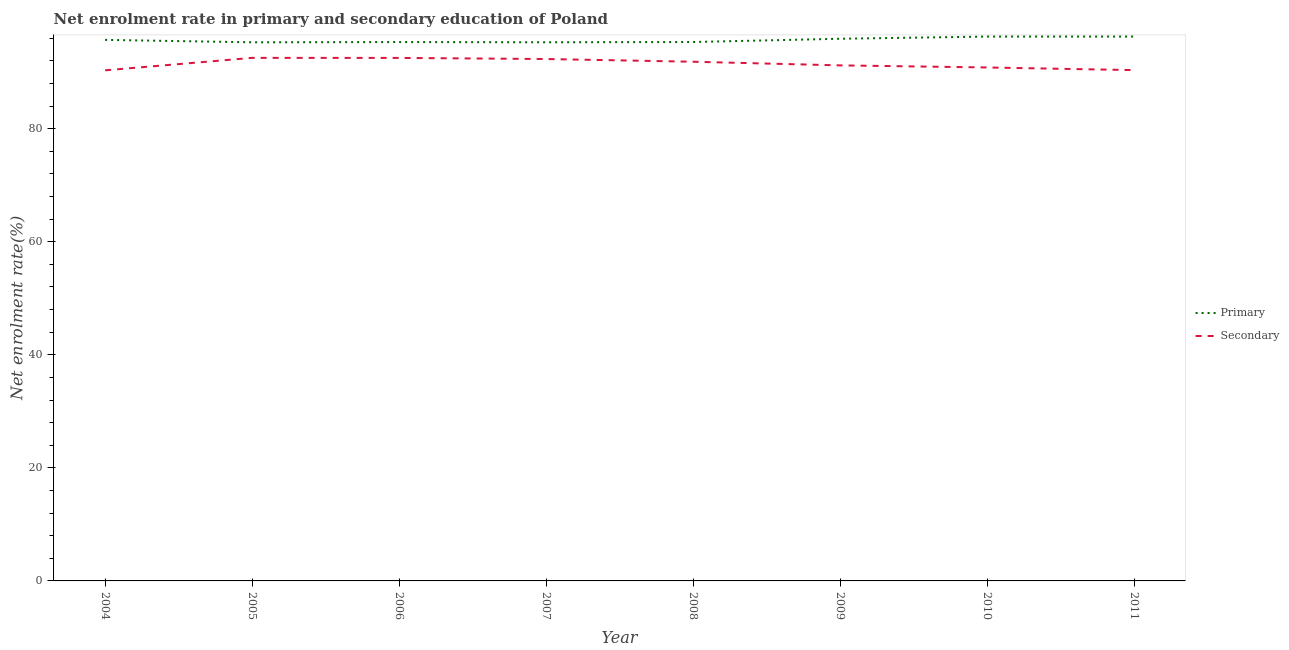What is the enrollment rate in primary education in 2007?
Offer a very short reply. 95.29. Across all years, what is the maximum enrollment rate in primary education?
Ensure brevity in your answer.  96.3. Across all years, what is the minimum enrollment rate in secondary education?
Your answer should be compact. 90.33. What is the total enrollment rate in primary education in the graph?
Make the answer very short. 765.48. What is the difference between the enrollment rate in primary education in 2005 and that in 2007?
Offer a very short reply. -0. What is the difference between the enrollment rate in primary education in 2009 and the enrollment rate in secondary education in 2005?
Make the answer very short. 3.38. What is the average enrollment rate in primary education per year?
Make the answer very short. 95.69. In the year 2007, what is the difference between the enrollment rate in primary education and enrollment rate in secondary education?
Your answer should be very brief. 2.96. What is the ratio of the enrollment rate in primary education in 2006 to that in 2008?
Provide a short and direct response. 1. What is the difference between the highest and the second highest enrollment rate in secondary education?
Ensure brevity in your answer.  0.01. What is the difference between the highest and the lowest enrollment rate in primary education?
Your answer should be compact. 1.01. Is the sum of the enrollment rate in secondary education in 2007 and 2010 greater than the maximum enrollment rate in primary education across all years?
Provide a succinct answer. Yes. Does the enrollment rate in primary education monotonically increase over the years?
Make the answer very short. No. Is the enrollment rate in primary education strictly greater than the enrollment rate in secondary education over the years?
Your answer should be compact. Yes. Are the values on the major ticks of Y-axis written in scientific E-notation?
Offer a terse response. No. Does the graph contain grids?
Keep it short and to the point. No. How are the legend labels stacked?
Your answer should be compact. Vertical. What is the title of the graph?
Offer a very short reply. Net enrolment rate in primary and secondary education of Poland. What is the label or title of the X-axis?
Give a very brief answer. Year. What is the label or title of the Y-axis?
Your answer should be very brief. Net enrolment rate(%). What is the Net enrolment rate(%) in Primary in 2004?
Make the answer very short. 95.71. What is the Net enrolment rate(%) in Secondary in 2004?
Your answer should be very brief. 90.33. What is the Net enrolment rate(%) in Primary in 2005?
Your answer should be compact. 95.29. What is the Net enrolment rate(%) in Secondary in 2005?
Your answer should be compact. 92.53. What is the Net enrolment rate(%) of Primary in 2006?
Give a very brief answer. 95.33. What is the Net enrolment rate(%) of Secondary in 2006?
Ensure brevity in your answer.  92.52. What is the Net enrolment rate(%) of Primary in 2007?
Ensure brevity in your answer.  95.29. What is the Net enrolment rate(%) of Secondary in 2007?
Keep it short and to the point. 92.33. What is the Net enrolment rate(%) in Primary in 2008?
Ensure brevity in your answer.  95.34. What is the Net enrolment rate(%) of Secondary in 2008?
Your response must be concise. 91.85. What is the Net enrolment rate(%) of Primary in 2009?
Your response must be concise. 95.92. What is the Net enrolment rate(%) of Secondary in 2009?
Ensure brevity in your answer.  91.21. What is the Net enrolment rate(%) in Primary in 2010?
Your answer should be compact. 96.3. What is the Net enrolment rate(%) in Secondary in 2010?
Your answer should be compact. 90.84. What is the Net enrolment rate(%) in Primary in 2011?
Provide a succinct answer. 96.3. What is the Net enrolment rate(%) of Secondary in 2011?
Give a very brief answer. 90.37. Across all years, what is the maximum Net enrolment rate(%) of Primary?
Make the answer very short. 96.3. Across all years, what is the maximum Net enrolment rate(%) in Secondary?
Offer a very short reply. 92.53. Across all years, what is the minimum Net enrolment rate(%) in Primary?
Offer a very short reply. 95.29. Across all years, what is the minimum Net enrolment rate(%) of Secondary?
Make the answer very short. 90.33. What is the total Net enrolment rate(%) in Primary in the graph?
Ensure brevity in your answer.  765.48. What is the total Net enrolment rate(%) of Secondary in the graph?
Keep it short and to the point. 731.98. What is the difference between the Net enrolment rate(%) in Primary in 2004 and that in 2005?
Make the answer very short. 0.42. What is the difference between the Net enrolment rate(%) of Secondary in 2004 and that in 2005?
Make the answer very short. -2.2. What is the difference between the Net enrolment rate(%) of Primary in 2004 and that in 2006?
Your response must be concise. 0.38. What is the difference between the Net enrolment rate(%) of Secondary in 2004 and that in 2006?
Your response must be concise. -2.19. What is the difference between the Net enrolment rate(%) in Primary in 2004 and that in 2007?
Your answer should be compact. 0.42. What is the difference between the Net enrolment rate(%) in Secondary in 2004 and that in 2007?
Provide a succinct answer. -2. What is the difference between the Net enrolment rate(%) of Primary in 2004 and that in 2008?
Your response must be concise. 0.38. What is the difference between the Net enrolment rate(%) of Secondary in 2004 and that in 2008?
Provide a succinct answer. -1.52. What is the difference between the Net enrolment rate(%) of Primary in 2004 and that in 2009?
Keep it short and to the point. -0.2. What is the difference between the Net enrolment rate(%) in Secondary in 2004 and that in 2009?
Make the answer very short. -0.87. What is the difference between the Net enrolment rate(%) of Primary in 2004 and that in 2010?
Your answer should be compact. -0.59. What is the difference between the Net enrolment rate(%) in Secondary in 2004 and that in 2010?
Give a very brief answer. -0.5. What is the difference between the Net enrolment rate(%) of Primary in 2004 and that in 2011?
Your answer should be very brief. -0.59. What is the difference between the Net enrolment rate(%) in Secondary in 2004 and that in 2011?
Ensure brevity in your answer.  -0.04. What is the difference between the Net enrolment rate(%) of Primary in 2005 and that in 2006?
Offer a very short reply. -0.04. What is the difference between the Net enrolment rate(%) in Secondary in 2005 and that in 2006?
Keep it short and to the point. 0.01. What is the difference between the Net enrolment rate(%) in Primary in 2005 and that in 2007?
Your response must be concise. -0. What is the difference between the Net enrolment rate(%) of Secondary in 2005 and that in 2007?
Your answer should be very brief. 0.2. What is the difference between the Net enrolment rate(%) of Primary in 2005 and that in 2008?
Provide a succinct answer. -0.05. What is the difference between the Net enrolment rate(%) of Secondary in 2005 and that in 2008?
Provide a succinct answer. 0.68. What is the difference between the Net enrolment rate(%) in Primary in 2005 and that in 2009?
Offer a terse response. -0.63. What is the difference between the Net enrolment rate(%) of Secondary in 2005 and that in 2009?
Offer a terse response. 1.33. What is the difference between the Net enrolment rate(%) in Primary in 2005 and that in 2010?
Your answer should be compact. -1.01. What is the difference between the Net enrolment rate(%) in Secondary in 2005 and that in 2010?
Ensure brevity in your answer.  1.7. What is the difference between the Net enrolment rate(%) of Primary in 2005 and that in 2011?
Your answer should be very brief. -1.01. What is the difference between the Net enrolment rate(%) of Secondary in 2005 and that in 2011?
Your answer should be compact. 2.17. What is the difference between the Net enrolment rate(%) of Primary in 2006 and that in 2007?
Make the answer very short. 0.04. What is the difference between the Net enrolment rate(%) in Secondary in 2006 and that in 2007?
Provide a succinct answer. 0.19. What is the difference between the Net enrolment rate(%) in Primary in 2006 and that in 2008?
Make the answer very short. -0.01. What is the difference between the Net enrolment rate(%) of Secondary in 2006 and that in 2008?
Offer a terse response. 0.67. What is the difference between the Net enrolment rate(%) of Primary in 2006 and that in 2009?
Your answer should be compact. -0.59. What is the difference between the Net enrolment rate(%) of Secondary in 2006 and that in 2009?
Your response must be concise. 1.32. What is the difference between the Net enrolment rate(%) of Primary in 2006 and that in 2010?
Your answer should be compact. -0.97. What is the difference between the Net enrolment rate(%) in Secondary in 2006 and that in 2010?
Ensure brevity in your answer.  1.69. What is the difference between the Net enrolment rate(%) in Primary in 2006 and that in 2011?
Make the answer very short. -0.97. What is the difference between the Net enrolment rate(%) in Secondary in 2006 and that in 2011?
Your response must be concise. 2.16. What is the difference between the Net enrolment rate(%) of Primary in 2007 and that in 2008?
Your answer should be very brief. -0.04. What is the difference between the Net enrolment rate(%) in Secondary in 2007 and that in 2008?
Keep it short and to the point. 0.48. What is the difference between the Net enrolment rate(%) in Primary in 2007 and that in 2009?
Ensure brevity in your answer.  -0.62. What is the difference between the Net enrolment rate(%) of Secondary in 2007 and that in 2009?
Offer a terse response. 1.13. What is the difference between the Net enrolment rate(%) of Primary in 2007 and that in 2010?
Ensure brevity in your answer.  -1.01. What is the difference between the Net enrolment rate(%) of Secondary in 2007 and that in 2010?
Keep it short and to the point. 1.5. What is the difference between the Net enrolment rate(%) of Primary in 2007 and that in 2011?
Keep it short and to the point. -1.01. What is the difference between the Net enrolment rate(%) of Secondary in 2007 and that in 2011?
Ensure brevity in your answer.  1.96. What is the difference between the Net enrolment rate(%) in Primary in 2008 and that in 2009?
Offer a very short reply. -0.58. What is the difference between the Net enrolment rate(%) of Secondary in 2008 and that in 2009?
Provide a succinct answer. 0.64. What is the difference between the Net enrolment rate(%) in Primary in 2008 and that in 2010?
Give a very brief answer. -0.96. What is the difference between the Net enrolment rate(%) of Secondary in 2008 and that in 2010?
Provide a short and direct response. 1.01. What is the difference between the Net enrolment rate(%) in Primary in 2008 and that in 2011?
Your answer should be very brief. -0.97. What is the difference between the Net enrolment rate(%) in Secondary in 2008 and that in 2011?
Keep it short and to the point. 1.48. What is the difference between the Net enrolment rate(%) of Primary in 2009 and that in 2010?
Offer a terse response. -0.38. What is the difference between the Net enrolment rate(%) of Secondary in 2009 and that in 2010?
Offer a terse response. 0.37. What is the difference between the Net enrolment rate(%) in Primary in 2009 and that in 2011?
Provide a short and direct response. -0.39. What is the difference between the Net enrolment rate(%) in Secondary in 2009 and that in 2011?
Keep it short and to the point. 0.84. What is the difference between the Net enrolment rate(%) in Primary in 2010 and that in 2011?
Provide a succinct answer. -0. What is the difference between the Net enrolment rate(%) of Secondary in 2010 and that in 2011?
Offer a terse response. 0.47. What is the difference between the Net enrolment rate(%) in Primary in 2004 and the Net enrolment rate(%) in Secondary in 2005?
Your response must be concise. 3.18. What is the difference between the Net enrolment rate(%) in Primary in 2004 and the Net enrolment rate(%) in Secondary in 2006?
Provide a succinct answer. 3.19. What is the difference between the Net enrolment rate(%) in Primary in 2004 and the Net enrolment rate(%) in Secondary in 2007?
Offer a very short reply. 3.38. What is the difference between the Net enrolment rate(%) in Primary in 2004 and the Net enrolment rate(%) in Secondary in 2008?
Provide a short and direct response. 3.86. What is the difference between the Net enrolment rate(%) in Primary in 2004 and the Net enrolment rate(%) in Secondary in 2009?
Your response must be concise. 4.51. What is the difference between the Net enrolment rate(%) in Primary in 2004 and the Net enrolment rate(%) in Secondary in 2010?
Your response must be concise. 4.88. What is the difference between the Net enrolment rate(%) in Primary in 2004 and the Net enrolment rate(%) in Secondary in 2011?
Offer a terse response. 5.35. What is the difference between the Net enrolment rate(%) of Primary in 2005 and the Net enrolment rate(%) of Secondary in 2006?
Make the answer very short. 2.76. What is the difference between the Net enrolment rate(%) of Primary in 2005 and the Net enrolment rate(%) of Secondary in 2007?
Your answer should be compact. 2.96. What is the difference between the Net enrolment rate(%) in Primary in 2005 and the Net enrolment rate(%) in Secondary in 2008?
Your answer should be very brief. 3.44. What is the difference between the Net enrolment rate(%) in Primary in 2005 and the Net enrolment rate(%) in Secondary in 2009?
Keep it short and to the point. 4.08. What is the difference between the Net enrolment rate(%) in Primary in 2005 and the Net enrolment rate(%) in Secondary in 2010?
Offer a terse response. 4.45. What is the difference between the Net enrolment rate(%) of Primary in 2005 and the Net enrolment rate(%) of Secondary in 2011?
Your response must be concise. 4.92. What is the difference between the Net enrolment rate(%) in Primary in 2006 and the Net enrolment rate(%) in Secondary in 2007?
Make the answer very short. 3. What is the difference between the Net enrolment rate(%) of Primary in 2006 and the Net enrolment rate(%) of Secondary in 2008?
Make the answer very short. 3.48. What is the difference between the Net enrolment rate(%) in Primary in 2006 and the Net enrolment rate(%) in Secondary in 2009?
Provide a succinct answer. 4.12. What is the difference between the Net enrolment rate(%) in Primary in 2006 and the Net enrolment rate(%) in Secondary in 2010?
Provide a succinct answer. 4.49. What is the difference between the Net enrolment rate(%) in Primary in 2006 and the Net enrolment rate(%) in Secondary in 2011?
Your answer should be compact. 4.96. What is the difference between the Net enrolment rate(%) in Primary in 2007 and the Net enrolment rate(%) in Secondary in 2008?
Your answer should be compact. 3.44. What is the difference between the Net enrolment rate(%) in Primary in 2007 and the Net enrolment rate(%) in Secondary in 2009?
Your answer should be very brief. 4.09. What is the difference between the Net enrolment rate(%) in Primary in 2007 and the Net enrolment rate(%) in Secondary in 2010?
Offer a very short reply. 4.46. What is the difference between the Net enrolment rate(%) of Primary in 2007 and the Net enrolment rate(%) of Secondary in 2011?
Provide a short and direct response. 4.93. What is the difference between the Net enrolment rate(%) of Primary in 2008 and the Net enrolment rate(%) of Secondary in 2009?
Provide a succinct answer. 4.13. What is the difference between the Net enrolment rate(%) of Primary in 2008 and the Net enrolment rate(%) of Secondary in 2010?
Your answer should be very brief. 4.5. What is the difference between the Net enrolment rate(%) of Primary in 2008 and the Net enrolment rate(%) of Secondary in 2011?
Give a very brief answer. 4.97. What is the difference between the Net enrolment rate(%) of Primary in 2009 and the Net enrolment rate(%) of Secondary in 2010?
Make the answer very short. 5.08. What is the difference between the Net enrolment rate(%) in Primary in 2009 and the Net enrolment rate(%) in Secondary in 2011?
Your answer should be very brief. 5.55. What is the difference between the Net enrolment rate(%) of Primary in 2010 and the Net enrolment rate(%) of Secondary in 2011?
Make the answer very short. 5.93. What is the average Net enrolment rate(%) in Primary per year?
Give a very brief answer. 95.69. What is the average Net enrolment rate(%) of Secondary per year?
Make the answer very short. 91.5. In the year 2004, what is the difference between the Net enrolment rate(%) of Primary and Net enrolment rate(%) of Secondary?
Offer a very short reply. 5.38. In the year 2005, what is the difference between the Net enrolment rate(%) in Primary and Net enrolment rate(%) in Secondary?
Provide a succinct answer. 2.76. In the year 2006, what is the difference between the Net enrolment rate(%) in Primary and Net enrolment rate(%) in Secondary?
Your answer should be very brief. 2.81. In the year 2007, what is the difference between the Net enrolment rate(%) of Primary and Net enrolment rate(%) of Secondary?
Give a very brief answer. 2.96. In the year 2008, what is the difference between the Net enrolment rate(%) in Primary and Net enrolment rate(%) in Secondary?
Provide a succinct answer. 3.49. In the year 2009, what is the difference between the Net enrolment rate(%) in Primary and Net enrolment rate(%) in Secondary?
Ensure brevity in your answer.  4.71. In the year 2010, what is the difference between the Net enrolment rate(%) in Primary and Net enrolment rate(%) in Secondary?
Offer a very short reply. 5.47. In the year 2011, what is the difference between the Net enrolment rate(%) of Primary and Net enrolment rate(%) of Secondary?
Keep it short and to the point. 5.94. What is the ratio of the Net enrolment rate(%) in Primary in 2004 to that in 2005?
Keep it short and to the point. 1. What is the ratio of the Net enrolment rate(%) in Secondary in 2004 to that in 2005?
Ensure brevity in your answer.  0.98. What is the ratio of the Net enrolment rate(%) of Secondary in 2004 to that in 2006?
Give a very brief answer. 0.98. What is the ratio of the Net enrolment rate(%) of Primary in 2004 to that in 2007?
Keep it short and to the point. 1. What is the ratio of the Net enrolment rate(%) of Secondary in 2004 to that in 2007?
Offer a terse response. 0.98. What is the ratio of the Net enrolment rate(%) in Secondary in 2004 to that in 2008?
Keep it short and to the point. 0.98. What is the ratio of the Net enrolment rate(%) of Secondary in 2004 to that in 2010?
Provide a short and direct response. 0.99. What is the ratio of the Net enrolment rate(%) of Primary in 2004 to that in 2011?
Offer a terse response. 0.99. What is the ratio of the Net enrolment rate(%) of Secondary in 2004 to that in 2011?
Offer a terse response. 1. What is the ratio of the Net enrolment rate(%) of Primary in 2005 to that in 2006?
Ensure brevity in your answer.  1. What is the ratio of the Net enrolment rate(%) of Secondary in 2005 to that in 2006?
Offer a terse response. 1. What is the ratio of the Net enrolment rate(%) of Primary in 2005 to that in 2007?
Keep it short and to the point. 1. What is the ratio of the Net enrolment rate(%) of Secondary in 2005 to that in 2007?
Your answer should be compact. 1. What is the ratio of the Net enrolment rate(%) of Primary in 2005 to that in 2008?
Provide a succinct answer. 1. What is the ratio of the Net enrolment rate(%) of Secondary in 2005 to that in 2008?
Ensure brevity in your answer.  1.01. What is the ratio of the Net enrolment rate(%) in Primary in 2005 to that in 2009?
Make the answer very short. 0.99. What is the ratio of the Net enrolment rate(%) of Secondary in 2005 to that in 2009?
Your answer should be compact. 1.01. What is the ratio of the Net enrolment rate(%) in Primary in 2005 to that in 2010?
Your response must be concise. 0.99. What is the ratio of the Net enrolment rate(%) in Secondary in 2005 to that in 2010?
Ensure brevity in your answer.  1.02. What is the ratio of the Net enrolment rate(%) of Primary in 2005 to that in 2011?
Make the answer very short. 0.99. What is the ratio of the Net enrolment rate(%) in Secondary in 2005 to that in 2011?
Provide a succinct answer. 1.02. What is the ratio of the Net enrolment rate(%) in Secondary in 2006 to that in 2007?
Your answer should be compact. 1. What is the ratio of the Net enrolment rate(%) in Primary in 2006 to that in 2008?
Make the answer very short. 1. What is the ratio of the Net enrolment rate(%) in Secondary in 2006 to that in 2008?
Provide a succinct answer. 1.01. What is the ratio of the Net enrolment rate(%) in Primary in 2006 to that in 2009?
Your answer should be compact. 0.99. What is the ratio of the Net enrolment rate(%) in Secondary in 2006 to that in 2009?
Give a very brief answer. 1.01. What is the ratio of the Net enrolment rate(%) in Primary in 2006 to that in 2010?
Your response must be concise. 0.99. What is the ratio of the Net enrolment rate(%) in Secondary in 2006 to that in 2010?
Ensure brevity in your answer.  1.02. What is the ratio of the Net enrolment rate(%) in Secondary in 2006 to that in 2011?
Ensure brevity in your answer.  1.02. What is the ratio of the Net enrolment rate(%) in Secondary in 2007 to that in 2008?
Your answer should be very brief. 1.01. What is the ratio of the Net enrolment rate(%) in Secondary in 2007 to that in 2009?
Your answer should be compact. 1.01. What is the ratio of the Net enrolment rate(%) of Secondary in 2007 to that in 2010?
Ensure brevity in your answer.  1.02. What is the ratio of the Net enrolment rate(%) in Secondary in 2007 to that in 2011?
Provide a succinct answer. 1.02. What is the ratio of the Net enrolment rate(%) in Secondary in 2008 to that in 2009?
Give a very brief answer. 1.01. What is the ratio of the Net enrolment rate(%) of Secondary in 2008 to that in 2010?
Provide a succinct answer. 1.01. What is the ratio of the Net enrolment rate(%) of Primary in 2008 to that in 2011?
Offer a very short reply. 0.99. What is the ratio of the Net enrolment rate(%) in Secondary in 2008 to that in 2011?
Provide a short and direct response. 1.02. What is the ratio of the Net enrolment rate(%) in Secondary in 2009 to that in 2010?
Ensure brevity in your answer.  1. What is the ratio of the Net enrolment rate(%) in Secondary in 2009 to that in 2011?
Provide a succinct answer. 1.01. What is the ratio of the Net enrolment rate(%) in Primary in 2010 to that in 2011?
Provide a short and direct response. 1. What is the ratio of the Net enrolment rate(%) of Secondary in 2010 to that in 2011?
Provide a short and direct response. 1.01. What is the difference between the highest and the second highest Net enrolment rate(%) of Primary?
Keep it short and to the point. 0. What is the difference between the highest and the second highest Net enrolment rate(%) in Secondary?
Offer a terse response. 0.01. What is the difference between the highest and the lowest Net enrolment rate(%) of Primary?
Provide a succinct answer. 1.01. What is the difference between the highest and the lowest Net enrolment rate(%) in Secondary?
Ensure brevity in your answer.  2.2. 